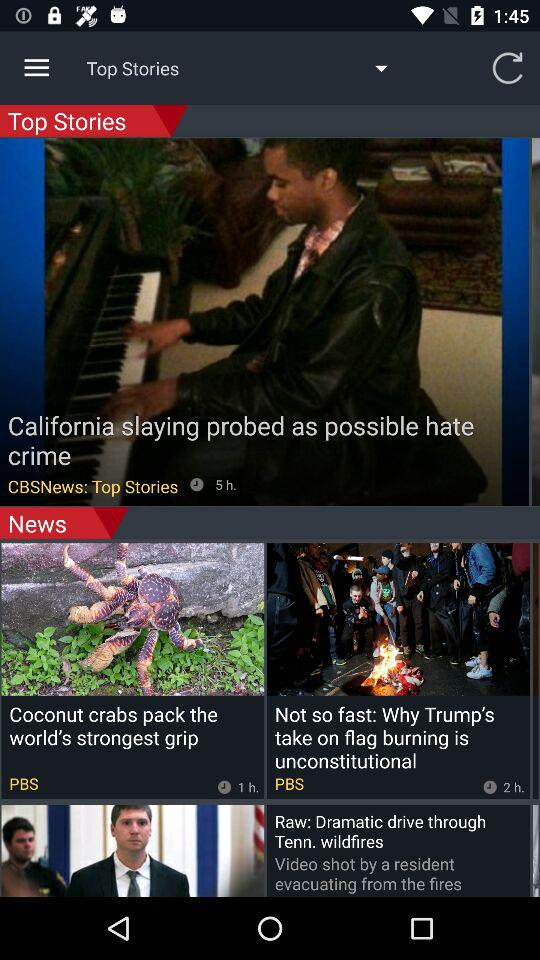What news channel uploaded the news to the top story? The name of the channel is CBS News. 